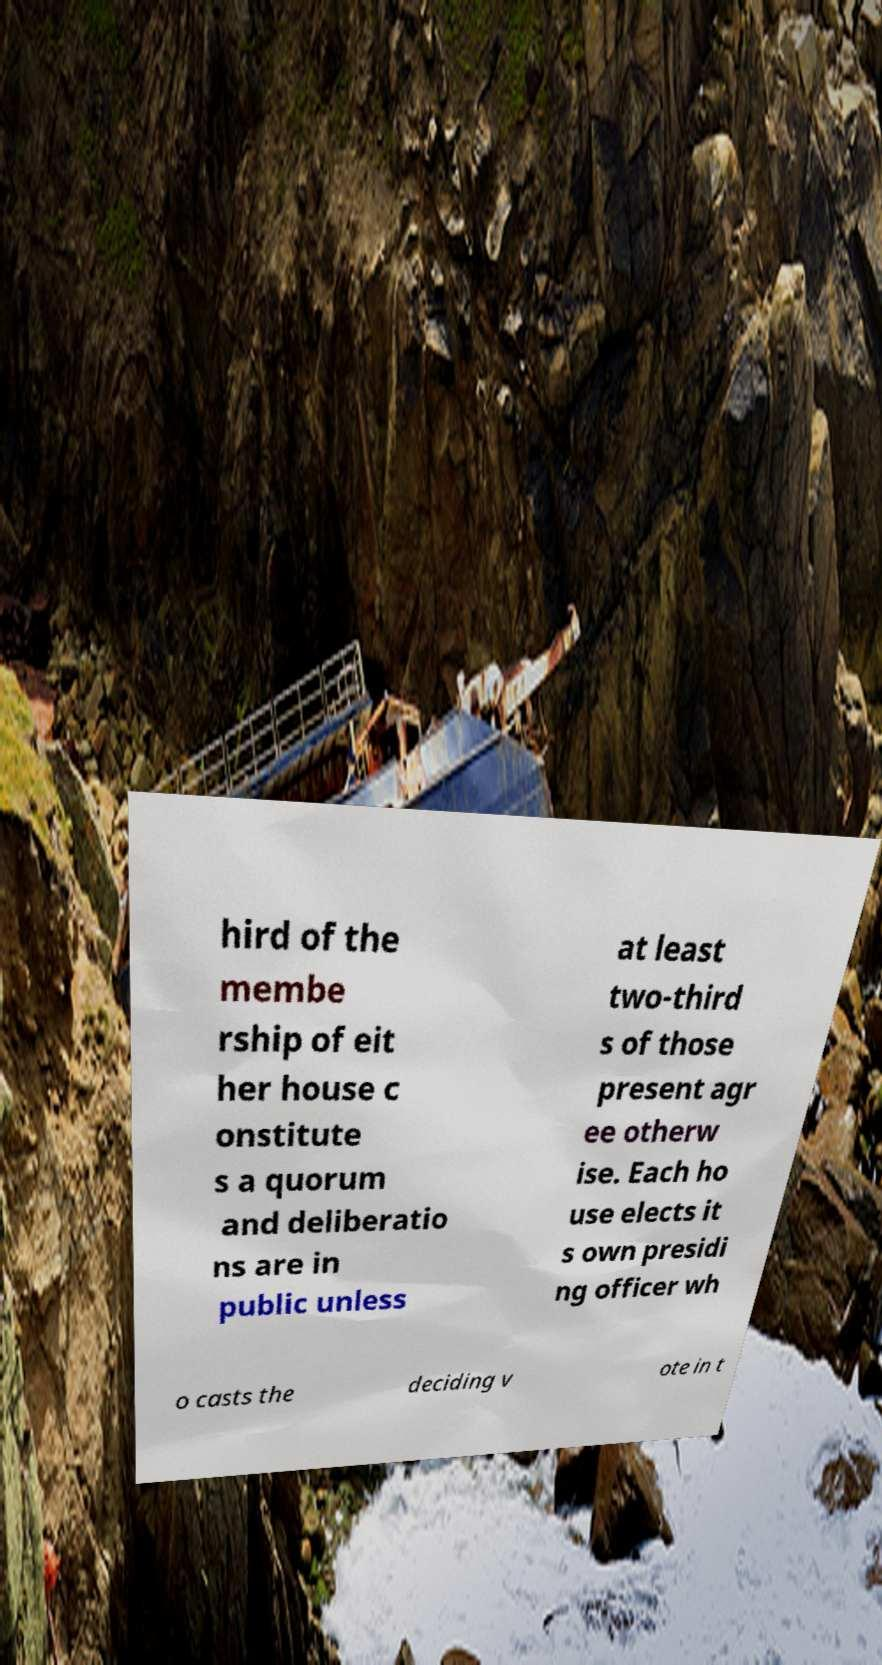For documentation purposes, I need the text within this image transcribed. Could you provide that? hird of the membe rship of eit her house c onstitute s a quorum and deliberatio ns are in public unless at least two-third s of those present agr ee otherw ise. Each ho use elects it s own presidi ng officer wh o casts the deciding v ote in t 